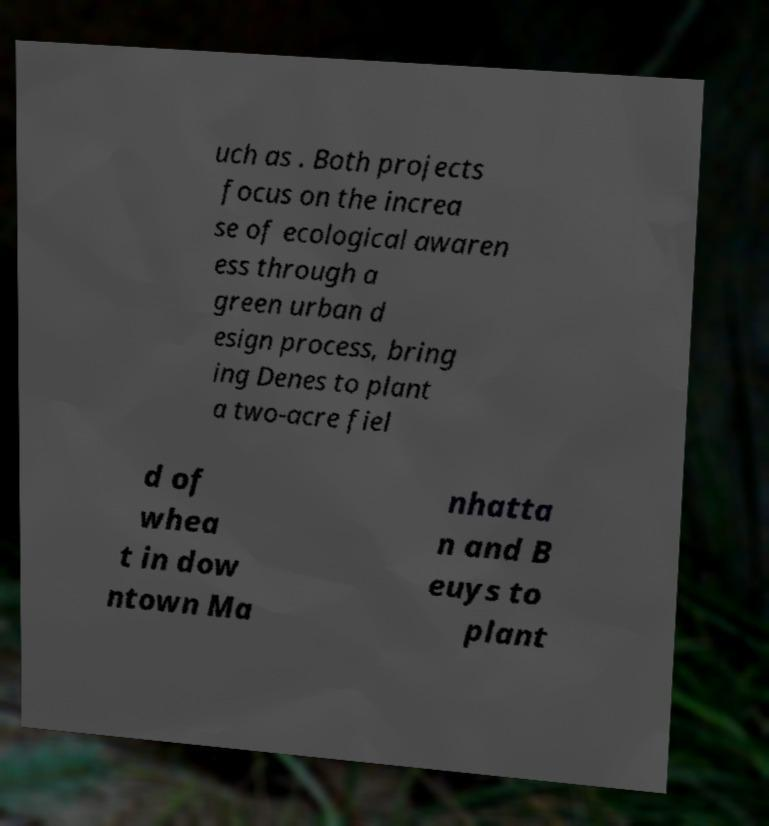Could you extract and type out the text from this image? uch as . Both projects focus on the increa se of ecological awaren ess through a green urban d esign process, bring ing Denes to plant a two-acre fiel d of whea t in dow ntown Ma nhatta n and B euys to plant 